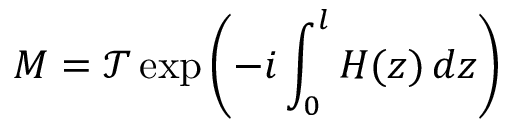Convert formula to latex. <formula><loc_0><loc_0><loc_500><loc_500>M = \mathcal { T } \exp { \left ( - i \int _ { 0 } ^ { l } H ( z ) \, d z \right ) }</formula> 